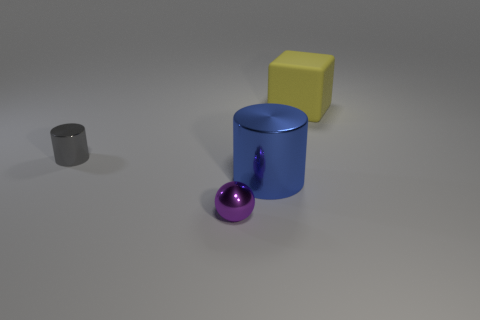How are the shadows positioned in relation to the objects? The shadows are cast towards the right side of the objects, suggesting that the light source is to their left. Each object creates a distinct shadow that corresponds to its shape.  Can you tell the texture of the surfaces? While a tactile analysis isn't possible from an image, visually, the surfaces of the objects appear smooth and matte with no visible texture. The floor has a slight reflective quality, which hints at a semi-gloss finish. 